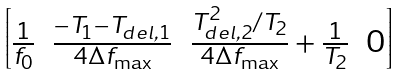Convert formula to latex. <formula><loc_0><loc_0><loc_500><loc_500>\begin{bmatrix} \frac { 1 } { f _ { 0 } } & \frac { - T _ { 1 } - T _ { d e l , 1 } } { 4 \Delta f _ { \max } } & \frac { T _ { d e l , 2 } ^ { 2 } / T _ { 2 } } { 4 \Delta f _ { \max } } + \frac { 1 } { T _ { 2 } } & 0 \end{bmatrix}</formula> 